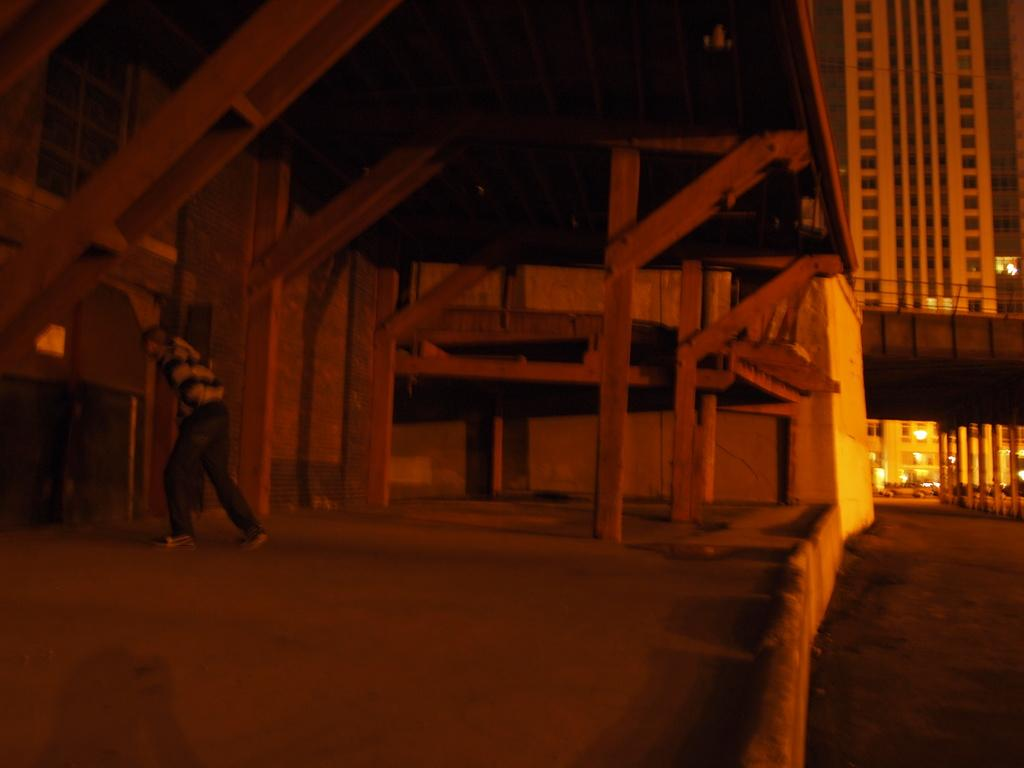What type of structures can be seen on the right side of the image? There are buildings and a bridge on the right side of the image. What type of transportation is visible in the image? There are vehicles in the image. What is the surface on which the vehicles are traveling? There is a road in the image. What can be seen on the left side of the image? There are wooden frames and a man standing on the left side of the image. What type of cable can be seen on the coast in the image? There is no coast or cable present in the image. What season is depicted in the image? The provided facts do not mention any seasonal details, so it cannot be determined from the image. 